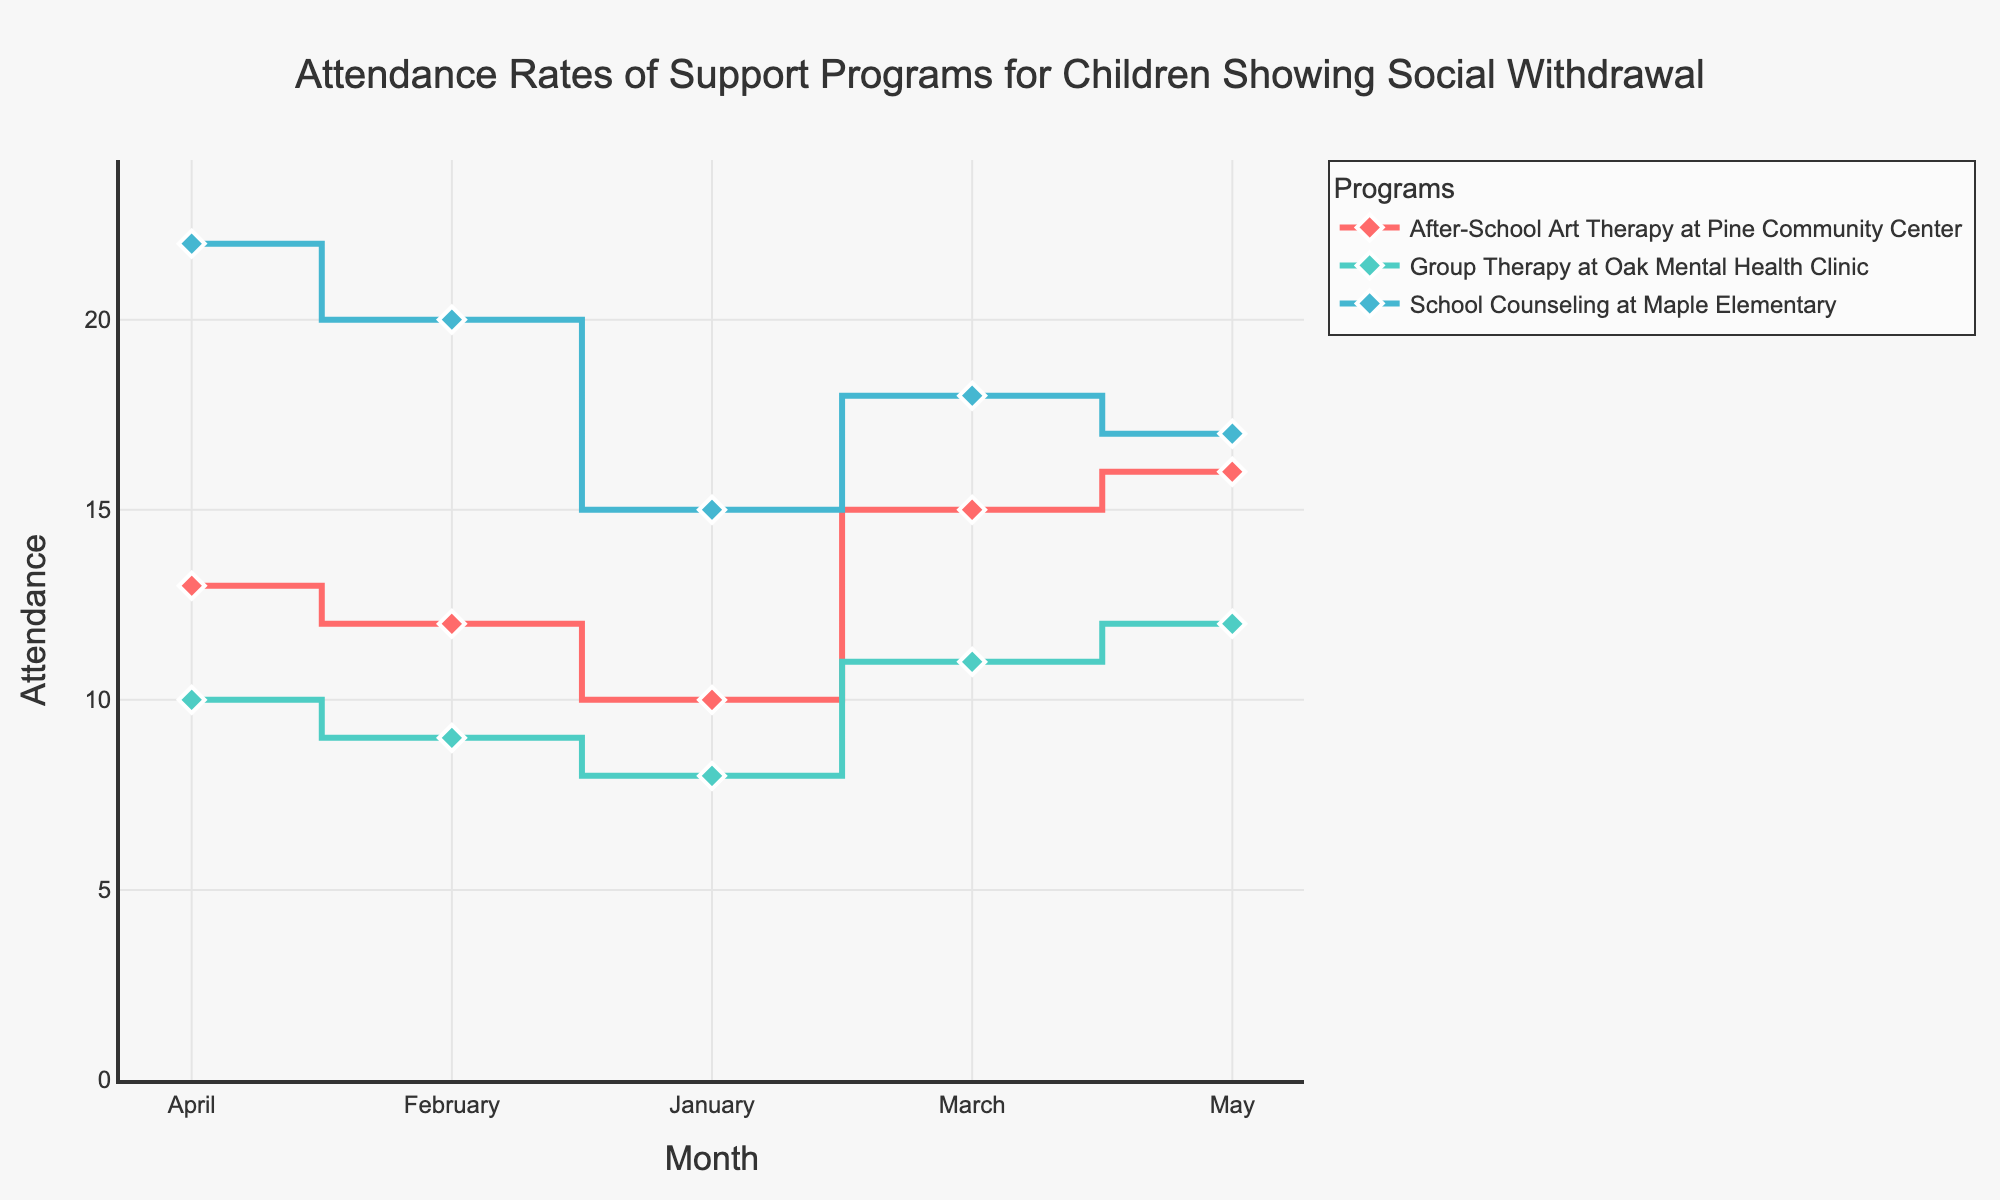What are the programs listed in the figure? The programs listed in the figure are shown as different lines, each with a unique legend entry. By looking at the legend, we can see the names of the programs.
Answer: "School Counseling at Maple Elementary", "After-School Art Therapy at Pine Community Center", "Group Therapy at Oak Mental Health Clinic" What trend can be observed in the attendance of "School Counseling at Maple Elementary" from January to May? To observe the trend, follow the line representing "School Counseling at Maple Elementary" from January to May. Note if it increases, decreases, or is erratic.
Answer: Increasing with some fluctuations Which month had the highest attendance for "After-School Art Therapy at Pine Community Center"? By tracing the line for "After-School Art Therapy at Pine Community Center" and identifying the month with the highest peak, we can determine the highest attendance month.
Answer: May What is the difference in attendance between "Group Therapy at Oak Mental Health Clinic" and "School Counseling at Maple Elementary" in March? Find the attendance values for both programs in March from the figure and subtract the value for "Group Therapy at Oak Mental Health Clinic" from "School Counseling at Maple Elementary".
Answer: 7 On average, how many children attended the "Group Therapy at Oak Mental Health Clinic" program per month? Add up the monthly attendance numbers for "Group Therapy at Oak Mental Health Clinic" and divide by the number of months (5).
Answer: 10 Which program showed the most fluctuation in attendance between January and May? To find the program with the most fluctuation, visually compare the variability in the lines representing each program, looking for the largest changes between months.
Answer: "School Counseling at Maple Elementary" In which month did the "School Counseling at Maple Elementary" program have the lowest attendance? Identify the lowest point on the line for "School Counseling at Maple Elementary" and note the corresponding month.
Answer: January How does the attendance in May for "After-School Art Therapy at Pine Community Center" compare to January? Compare the attendance values for "After-School Art Therapy at Pine Community Center" in May and January by observing the heights of the markers for those months.
Answer: Higher in May What's the total combined attendance for all programs in April? Sum the attendance numbers for all three programs in April by referring to their respective points in the figure.
Answer: 45 What pattern do you observe in the attendance for "Group Therapy at Oak Mental Health Clinic" over the five months? By examining the trajectory of the line for "Group Therapy at Oak Mental Health Clinic" across the months, identify if it shows increasing, decreasing, or stable attendance.
Answer: Slightly increasing fluctuation 